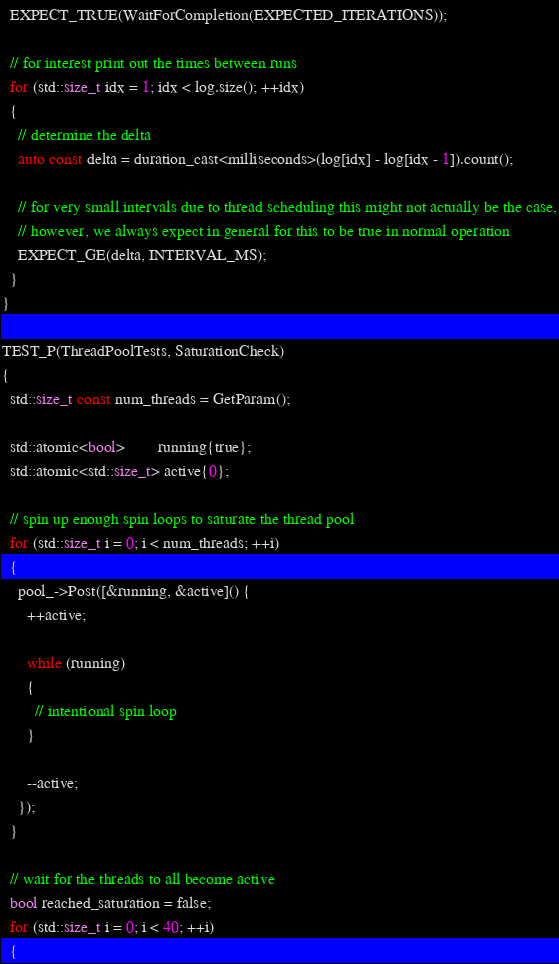Convert code to text. <code><loc_0><loc_0><loc_500><loc_500><_C++_>  EXPECT_TRUE(WaitForCompletion(EXPECTED_ITERATIONS));

  // for interest print out the times between runs
  for (std::size_t idx = 1; idx < log.size(); ++idx)
  {
    // determine the delta
    auto const delta = duration_cast<milliseconds>(log[idx] - log[idx - 1]).count();

    // for very small intervals due to thread scheduling this might not actually be the case,
    // however, we always expect in general for this to be true in normal operation
    EXPECT_GE(delta, INTERVAL_MS);
  }
}

TEST_P(ThreadPoolTests, SaturationCheck)
{
  std::size_t const num_threads = GetParam();

  std::atomic<bool>        running{true};
  std::atomic<std::size_t> active{0};

  // spin up enough spin loops to saturate the thread pool
  for (std::size_t i = 0; i < num_threads; ++i)
  {
    pool_->Post([&running, &active]() {
      ++active;

      while (running)
      {
        // intentional spin loop
      }

      --active;
    });
  }

  // wait for the threads to all become active
  bool reached_saturation = false;
  for (std::size_t i = 0; i < 40; ++i)
  {</code> 